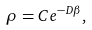<formula> <loc_0><loc_0><loc_500><loc_500>\rho = C e ^ { - D \beta } ,</formula> 